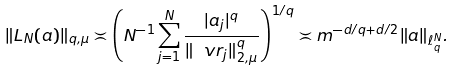<formula> <loc_0><loc_0><loc_500><loc_500>\| L _ { N } ( { a } ) \| _ { q , \mu } \asymp \left ( N ^ { - 1 } \sum _ { j = 1 } ^ { N } \frac { | a _ { j } | ^ { q } } { \| \ v r _ { j } \| _ { 2 , \mu } ^ { q } } \right ) ^ { 1 / q } \asymp m ^ { - d / q + d / 2 } \| { a } \| _ { \ell _ { q } ^ { N } } .</formula> 